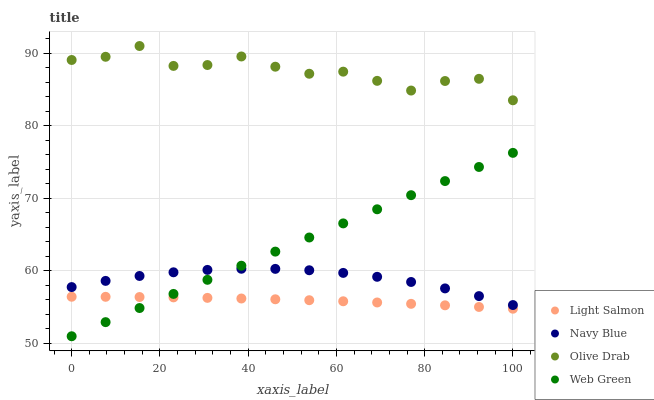Does Light Salmon have the minimum area under the curve?
Answer yes or no. Yes. Does Olive Drab have the maximum area under the curve?
Answer yes or no. Yes. Does Web Green have the minimum area under the curve?
Answer yes or no. No. Does Web Green have the maximum area under the curve?
Answer yes or no. No. Is Web Green the smoothest?
Answer yes or no. Yes. Is Olive Drab the roughest?
Answer yes or no. Yes. Is Light Salmon the smoothest?
Answer yes or no. No. Is Light Salmon the roughest?
Answer yes or no. No. Does Web Green have the lowest value?
Answer yes or no. Yes. Does Light Salmon have the lowest value?
Answer yes or no. No. Does Olive Drab have the highest value?
Answer yes or no. Yes. Does Web Green have the highest value?
Answer yes or no. No. Is Web Green less than Olive Drab?
Answer yes or no. Yes. Is Olive Drab greater than Navy Blue?
Answer yes or no. Yes. Does Web Green intersect Light Salmon?
Answer yes or no. Yes. Is Web Green less than Light Salmon?
Answer yes or no. No. Is Web Green greater than Light Salmon?
Answer yes or no. No. Does Web Green intersect Olive Drab?
Answer yes or no. No. 